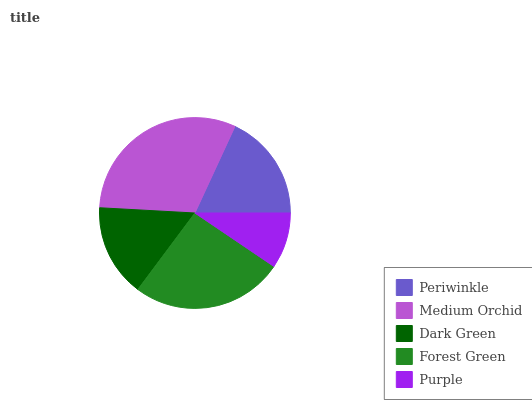Is Purple the minimum?
Answer yes or no. Yes. Is Medium Orchid the maximum?
Answer yes or no. Yes. Is Dark Green the minimum?
Answer yes or no. No. Is Dark Green the maximum?
Answer yes or no. No. Is Medium Orchid greater than Dark Green?
Answer yes or no. Yes. Is Dark Green less than Medium Orchid?
Answer yes or no. Yes. Is Dark Green greater than Medium Orchid?
Answer yes or no. No. Is Medium Orchid less than Dark Green?
Answer yes or no. No. Is Periwinkle the high median?
Answer yes or no. Yes. Is Periwinkle the low median?
Answer yes or no. Yes. Is Forest Green the high median?
Answer yes or no. No. Is Forest Green the low median?
Answer yes or no. No. 